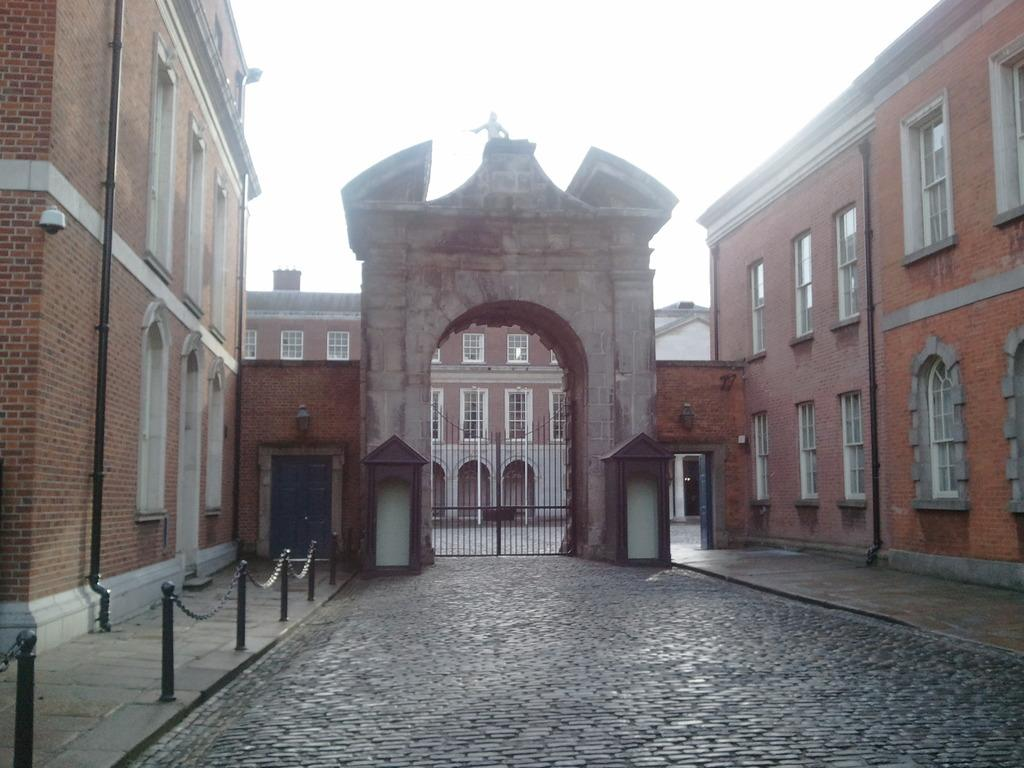What type of structures are present in the image? There are buildings with windows and doors in the image. Can you describe any additional features in the image? Yes, there is a gate in the image. What can be seen in the background of the image? In the background, there are poles and pipelines visible. What is visible at the bottom and top of the image? The ground and sky are visible in the image. What type of approval is required for the ship to pass through the gate in the image? There is no ship present in the image, so the question of approval is not applicable. 